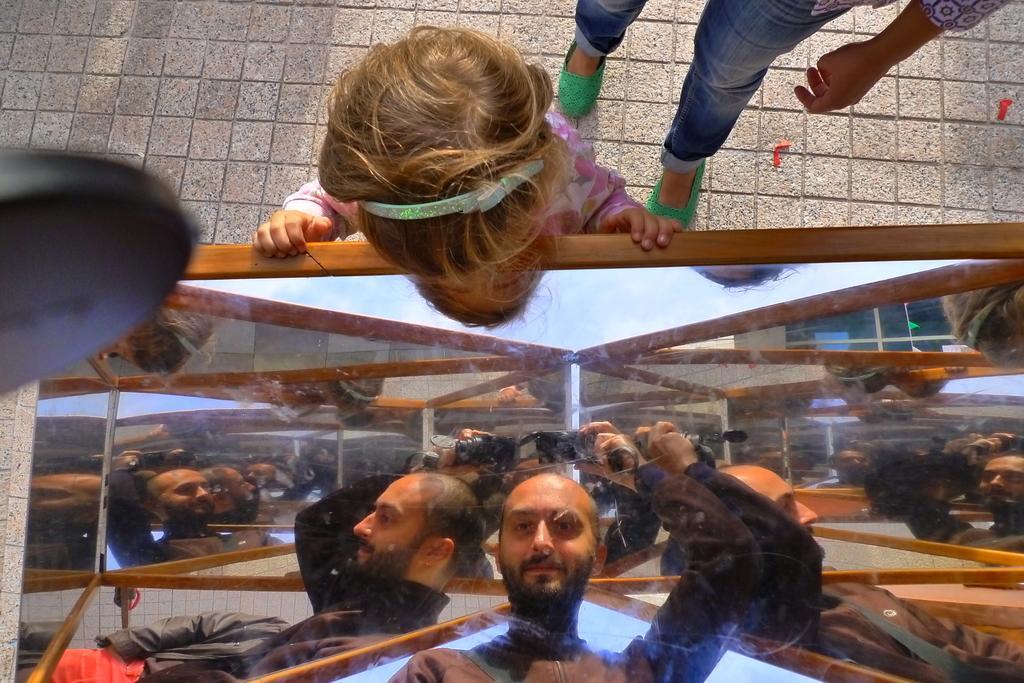Can you describe this image briefly? In this image we see there is a person inside the glass and there is a child looking this person. 